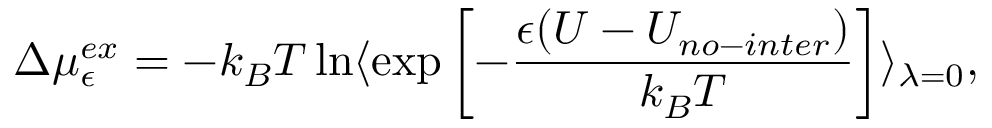Convert formula to latex. <formula><loc_0><loc_0><loc_500><loc_500>\Delta \mu _ { \epsilon } ^ { e x } = - k _ { B } T \ln { \langle { \exp \left [ - \frac { \epsilon ( U - U _ { n o - i n t e r } ) } { k _ { B } T } \right ] } \rangle } _ { \lambda = 0 } ,</formula> 